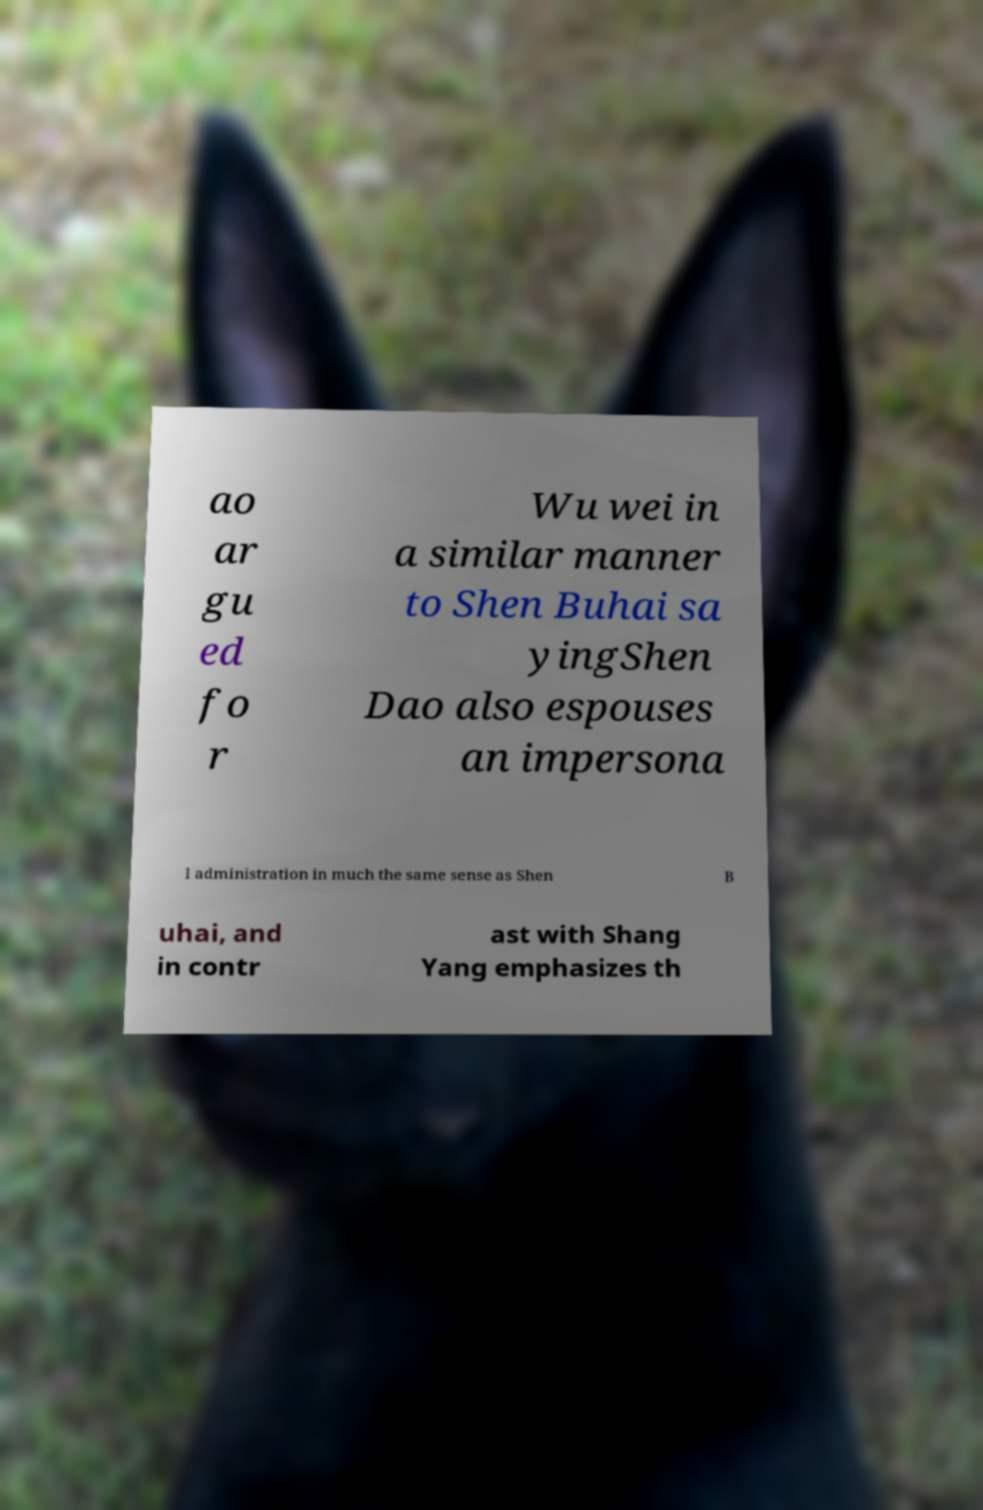Could you extract and type out the text from this image? ao ar gu ed fo r Wu wei in a similar manner to Shen Buhai sa yingShen Dao also espouses an impersona l administration in much the same sense as Shen B uhai, and in contr ast with Shang Yang emphasizes th 